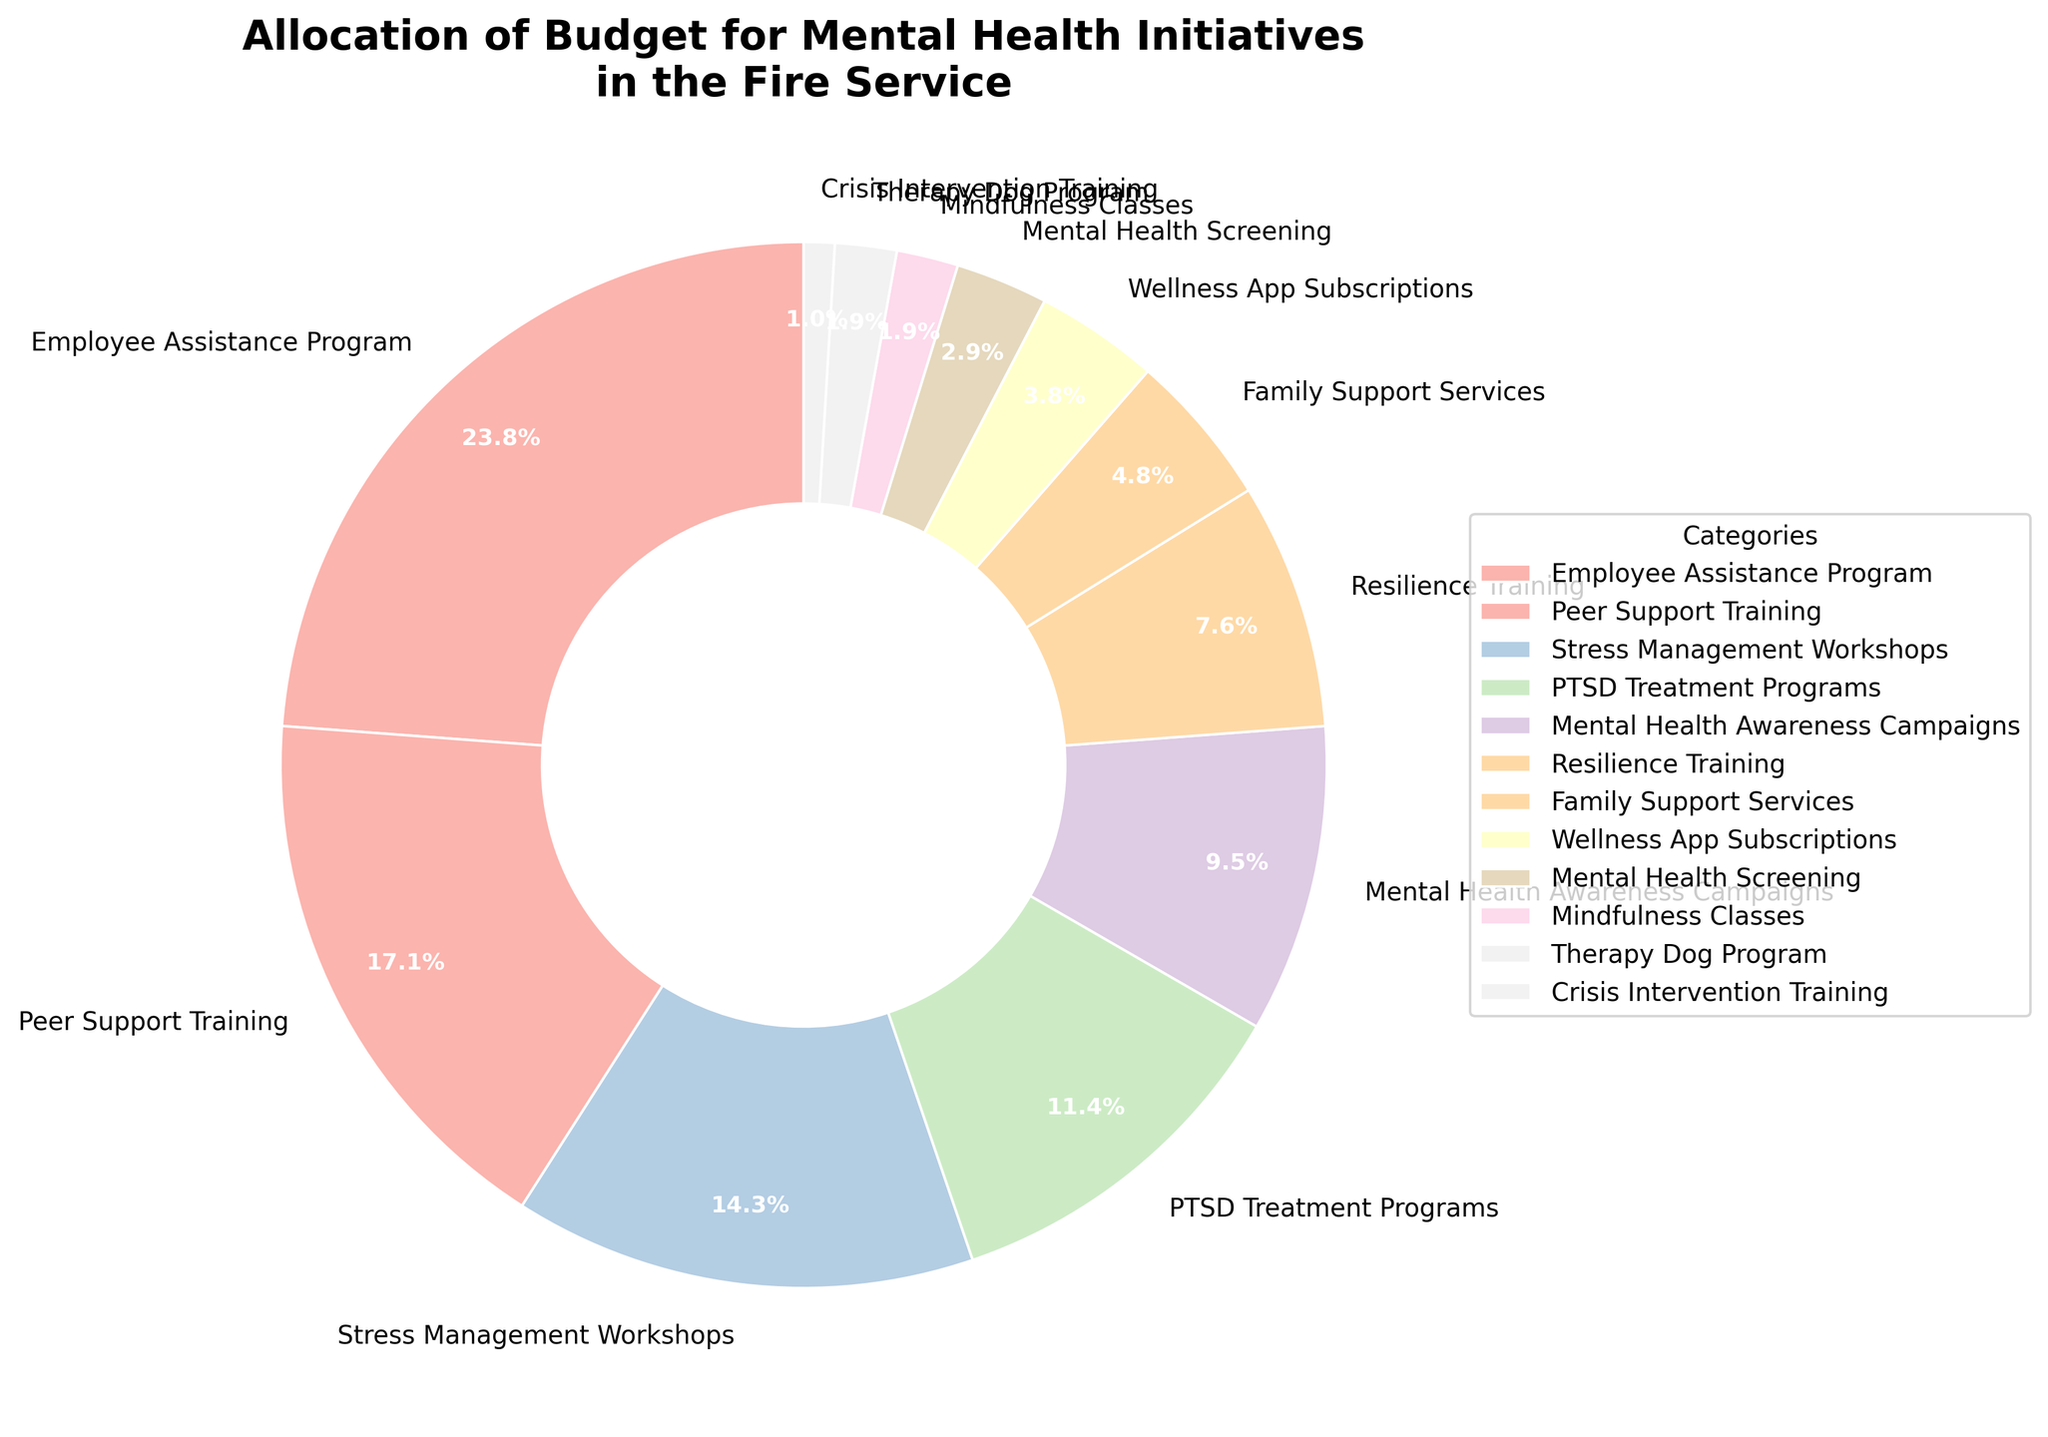Which category receives the highest percentage of the budget? To find the category receiving the highest percentage, look at the pie chart and identify the largest segment. In this case, it's the "Employee Assistance Program" segment.
Answer: Employee Assistance Program What is the combined percentage allocated to Peer Support Training and Stress Management Workshops? Add the percentages for Peer Support Training (18%) and Stress Management Workshops (15%). 18% + 15% = 33%.
Answer: 33% How does the budget allocation for Mental Health Awareness Campaigns compare to that for PTSD Treatment Programs? Compare the percentage slices for Mental Health Awareness Campaigns (10%) and PTSD Treatment Programs (12%). PTSD Treatment Programs receive 2% more.
Answer: PTSD Treatment Programs receive more Which category has the smallest budget allocation? Identify the smallest segment in the pie chart. This is the "Crisis Intervention Training" segment.
Answer: Crisis Intervention Training What is the difference in budget allocation between Wellness App Subscriptions and Mental Health Screening? Subtract the percentage for Mental Health Screening (3%) from Wellness App Subscriptions (4%). 4% - 3% = 1%.
Answer: 1% What is the average budget allocation for Mindfulness Classes, Therapy Dog Program, and Crisis Intervention Training? Add the percentages for Mindfulness Classes (2%), Therapy Dog Program (2%), and Crisis Intervention Training (1%), then divide by 3. (2% + 2% + 1%) / 3 = 1.67%.
Answer: 1.67% Summing up the smallest four budget categories, what is their combined allocation percentage? Add the percentages for the smallest four categories: Mindfulness Classes (2%), Therapy Dog Program (2%), Crisis Intervention Training (1%), and Mental Health Screening (3%). 2% + 2% + 1% + 3% = 8%.
Answer: 8% Which three categories combined make up the majority of the budget allocation? To find the majority, look for the three largest categories and add their percentages: Employee Assistance Program (25%), Peer Support Training (18%), and Stress Management Workshops (15%). Their sum is 25% + 18% + 15% = 58%.
Answer: Employee Assistance Program, Peer Support Training, and Stress Management Workshops Between Resilience Training and Family Support Services, which category receives a higher budget allocation, and by how much? Compare the percentages of Resilience Training (8%) and Family Support Services (5%). Resilience Training receives more by 8% - 5% = 3%.
Answer: Resilience Training by 3% What percentage of the budget is allocated to categories other than the top and bottom three budget categories? First, identify the top three (Employee Assistance Program, Peer Support Training, Stress Management Workshops: 25% + 18% + 15%) and bottom three categories (Therapy Dog Program, Crisis Intervention Training, Mindfulness Classes: 2% + 1% + 2%). Their combined percentage is 25% + 18% + 15% + 2% + 1% + 2% = 63%. Subtract this from 100%. 100% - 63% = 37%.
Answer: 37% 